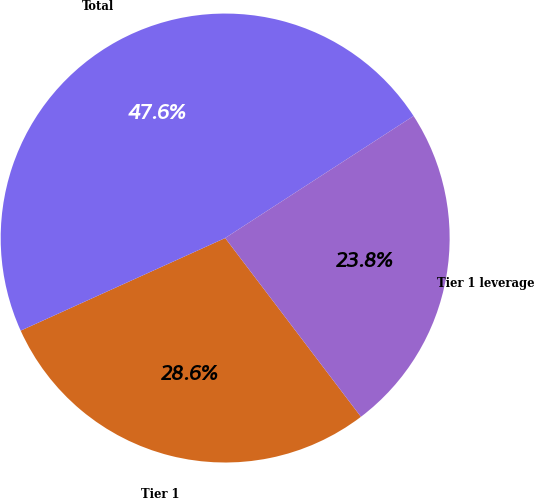Convert chart. <chart><loc_0><loc_0><loc_500><loc_500><pie_chart><fcel>Tier 1<fcel>Total<fcel>Tier 1 leverage<nl><fcel>28.57%<fcel>47.62%<fcel>23.81%<nl></chart> 